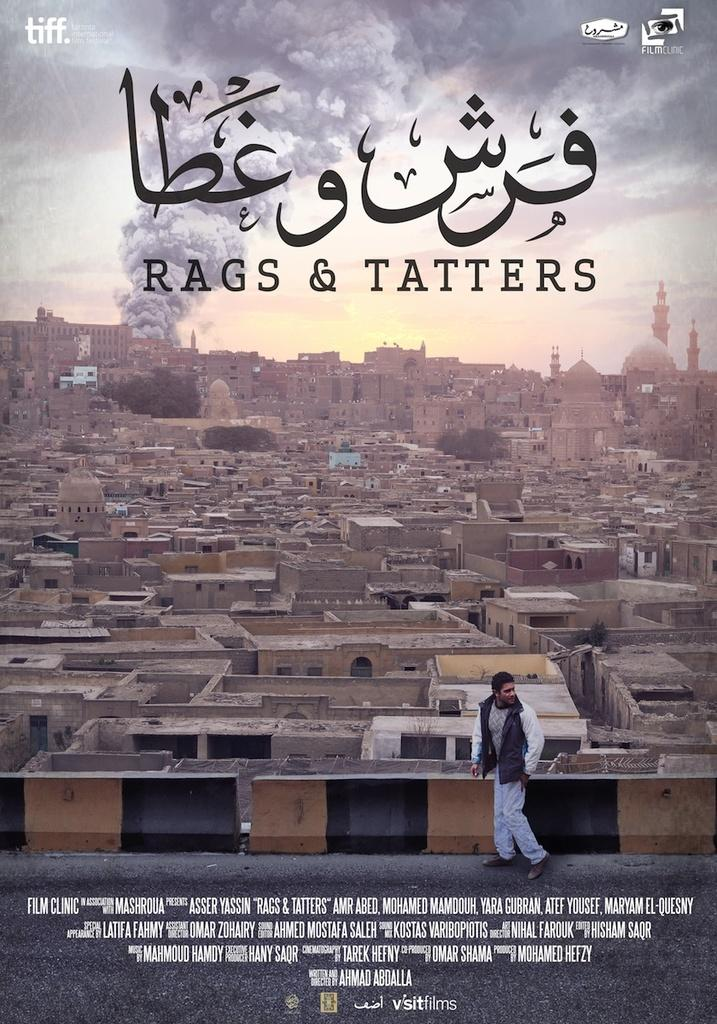Provide a one-sentence caption for the provided image. Movie poster that has a man walking in front of a favela titled "Rags & Tatters". 